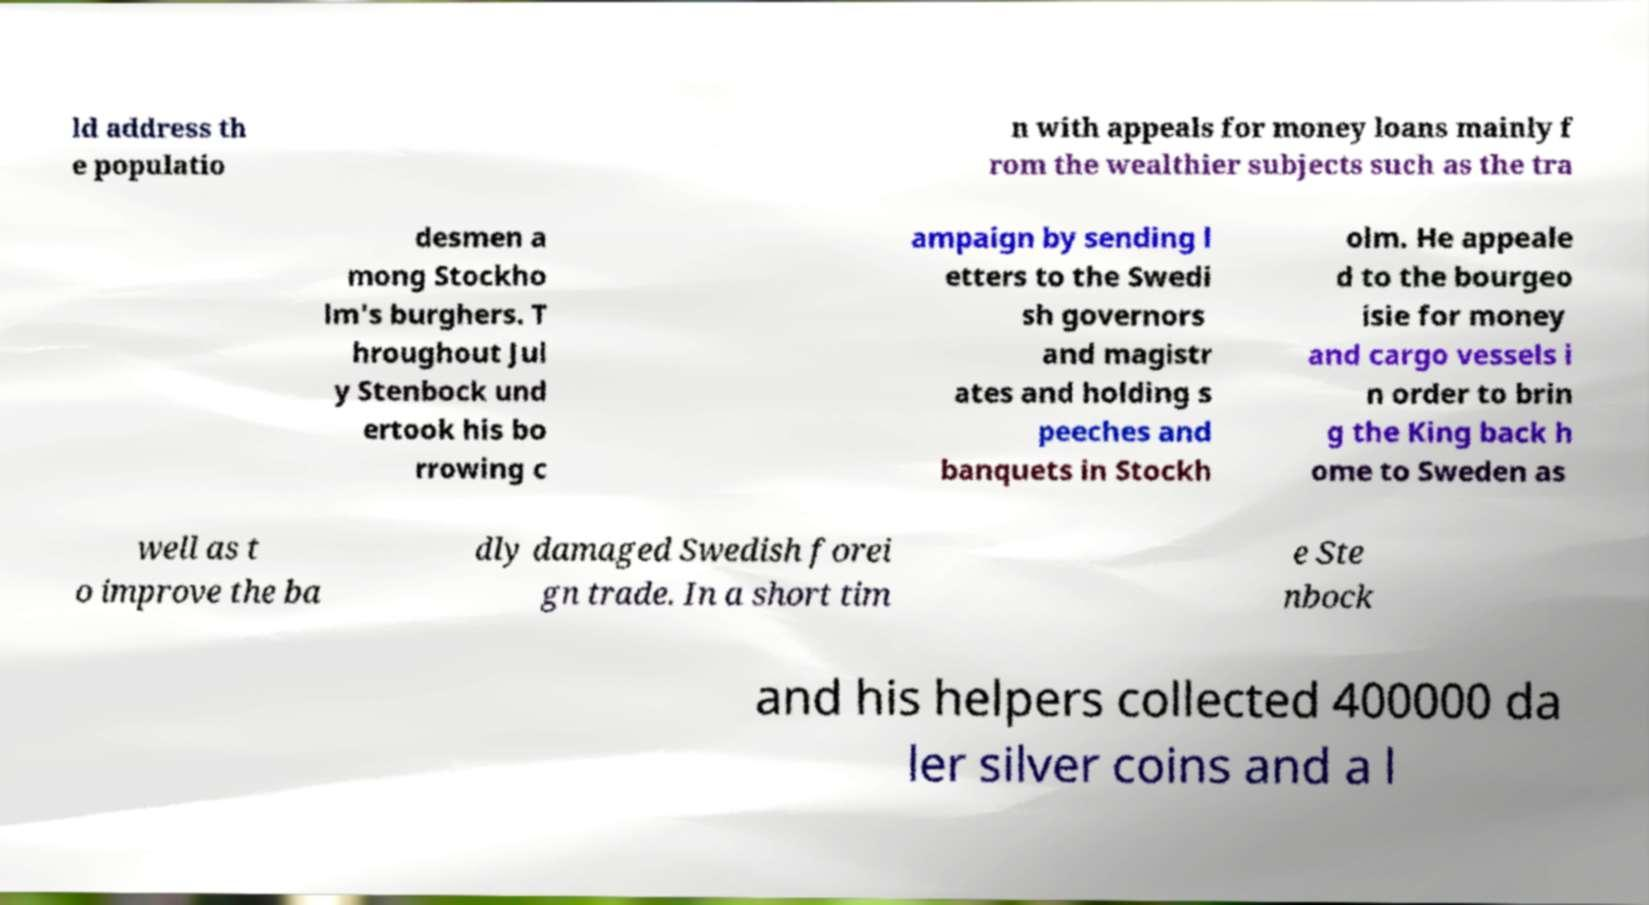Please read and relay the text visible in this image. What does it say? ld address th e populatio n with appeals for money loans mainly f rom the wealthier subjects such as the tra desmen a mong Stockho lm's burghers. T hroughout Jul y Stenbock und ertook his bo rrowing c ampaign by sending l etters to the Swedi sh governors and magistr ates and holding s peeches and banquets in Stockh olm. He appeale d to the bourgeo isie for money and cargo vessels i n order to brin g the King back h ome to Sweden as well as t o improve the ba dly damaged Swedish forei gn trade. In a short tim e Ste nbock and his helpers collected 400000 da ler silver coins and a l 